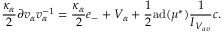<formula> <loc_0><loc_0><loc_500><loc_500>\frac { \kappa _ { \alpha } } { 2 } \partial v _ { \alpha } v _ { \alpha } ^ { - 1 } = \frac { \kappa _ { \alpha } } { 2 } e _ { - } + V _ { \alpha } + \frac { 1 } { 2 } a d ( \mu ^ { * } ) \frac { 1 } { I _ { V _ { a v } } } c .</formula> 